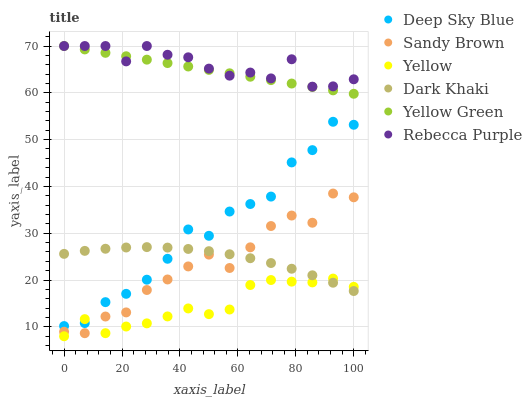Does Yellow have the minimum area under the curve?
Answer yes or no. Yes. Does Rebecca Purple have the maximum area under the curve?
Answer yes or no. Yes. Does Dark Khaki have the minimum area under the curve?
Answer yes or no. No. Does Dark Khaki have the maximum area under the curve?
Answer yes or no. No. Is Yellow Green the smoothest?
Answer yes or no. Yes. Is Deep Sky Blue the roughest?
Answer yes or no. Yes. Is Yellow the smoothest?
Answer yes or no. No. Is Yellow the roughest?
Answer yes or no. No. Does Yellow have the lowest value?
Answer yes or no. Yes. Does Dark Khaki have the lowest value?
Answer yes or no. No. Does Rebecca Purple have the highest value?
Answer yes or no. Yes. Does Dark Khaki have the highest value?
Answer yes or no. No. Is Yellow less than Yellow Green?
Answer yes or no. Yes. Is Rebecca Purple greater than Yellow?
Answer yes or no. Yes. Does Sandy Brown intersect Dark Khaki?
Answer yes or no. Yes. Is Sandy Brown less than Dark Khaki?
Answer yes or no. No. Is Sandy Brown greater than Dark Khaki?
Answer yes or no. No. Does Yellow intersect Yellow Green?
Answer yes or no. No. 